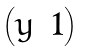Convert formula to latex. <formula><loc_0><loc_0><loc_500><loc_500>\begin{pmatrix} y & 1 \end{pmatrix}</formula> 